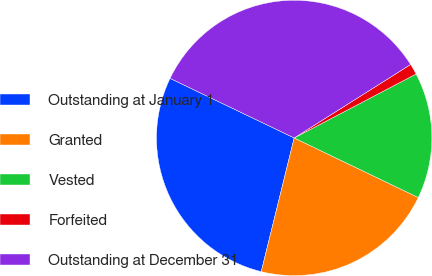Convert chart to OTSL. <chart><loc_0><loc_0><loc_500><loc_500><pie_chart><fcel>Outstanding at January 1<fcel>Granted<fcel>Vested<fcel>Forfeited<fcel>Outstanding at December 31<nl><fcel>28.28%<fcel>21.72%<fcel>14.81%<fcel>1.27%<fcel>33.92%<nl></chart> 